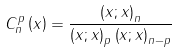Convert formula to latex. <formula><loc_0><loc_0><loc_500><loc_500>C _ { n } ^ { p } \left ( x \right ) = \frac { \left ( x ; x \right ) _ { n } } { \left ( x ; x \right ) _ { p } \left ( x ; x \right ) _ { n - p } }</formula> 